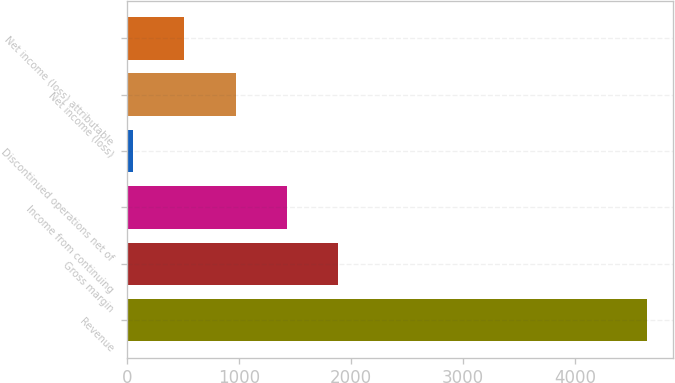<chart> <loc_0><loc_0><loc_500><loc_500><bar_chart><fcel>Revenue<fcel>Gross margin<fcel>Income from continuing<fcel>Discontinued operations net of<fcel>Net income (loss)<fcel>Net income (loss) attributable<nl><fcel>4640<fcel>1888.4<fcel>1429.8<fcel>54<fcel>971.2<fcel>512.6<nl></chart> 